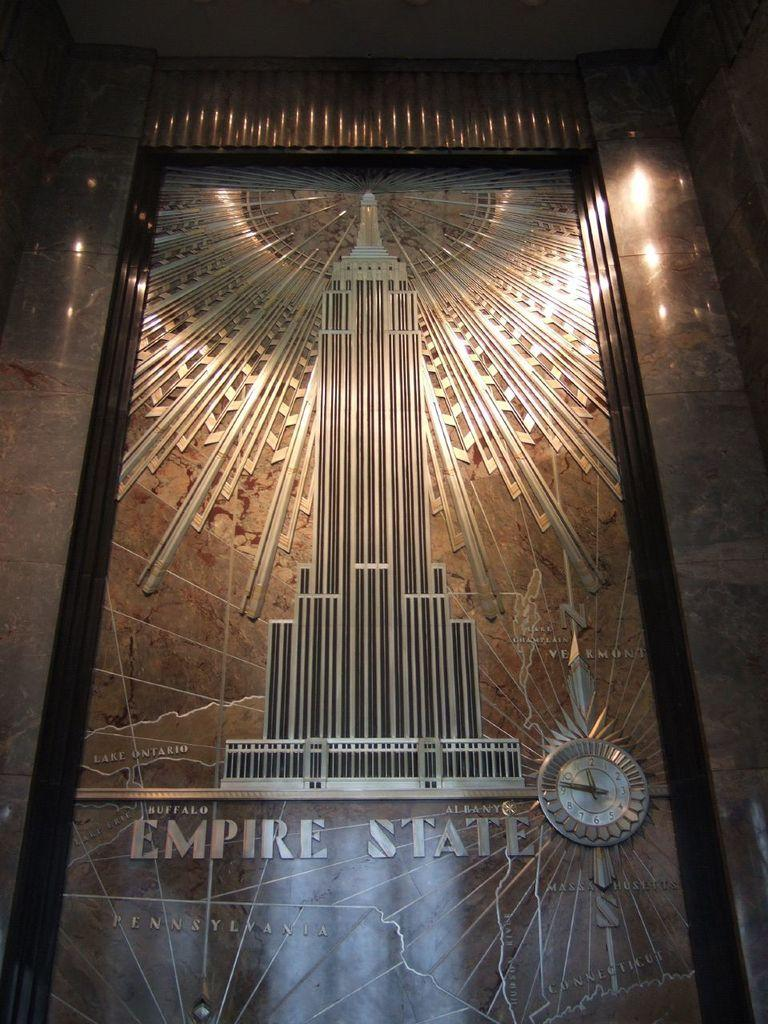<image>
Summarize the visual content of the image. A piece of artwork that features the Empire State Building is made out of metal. 